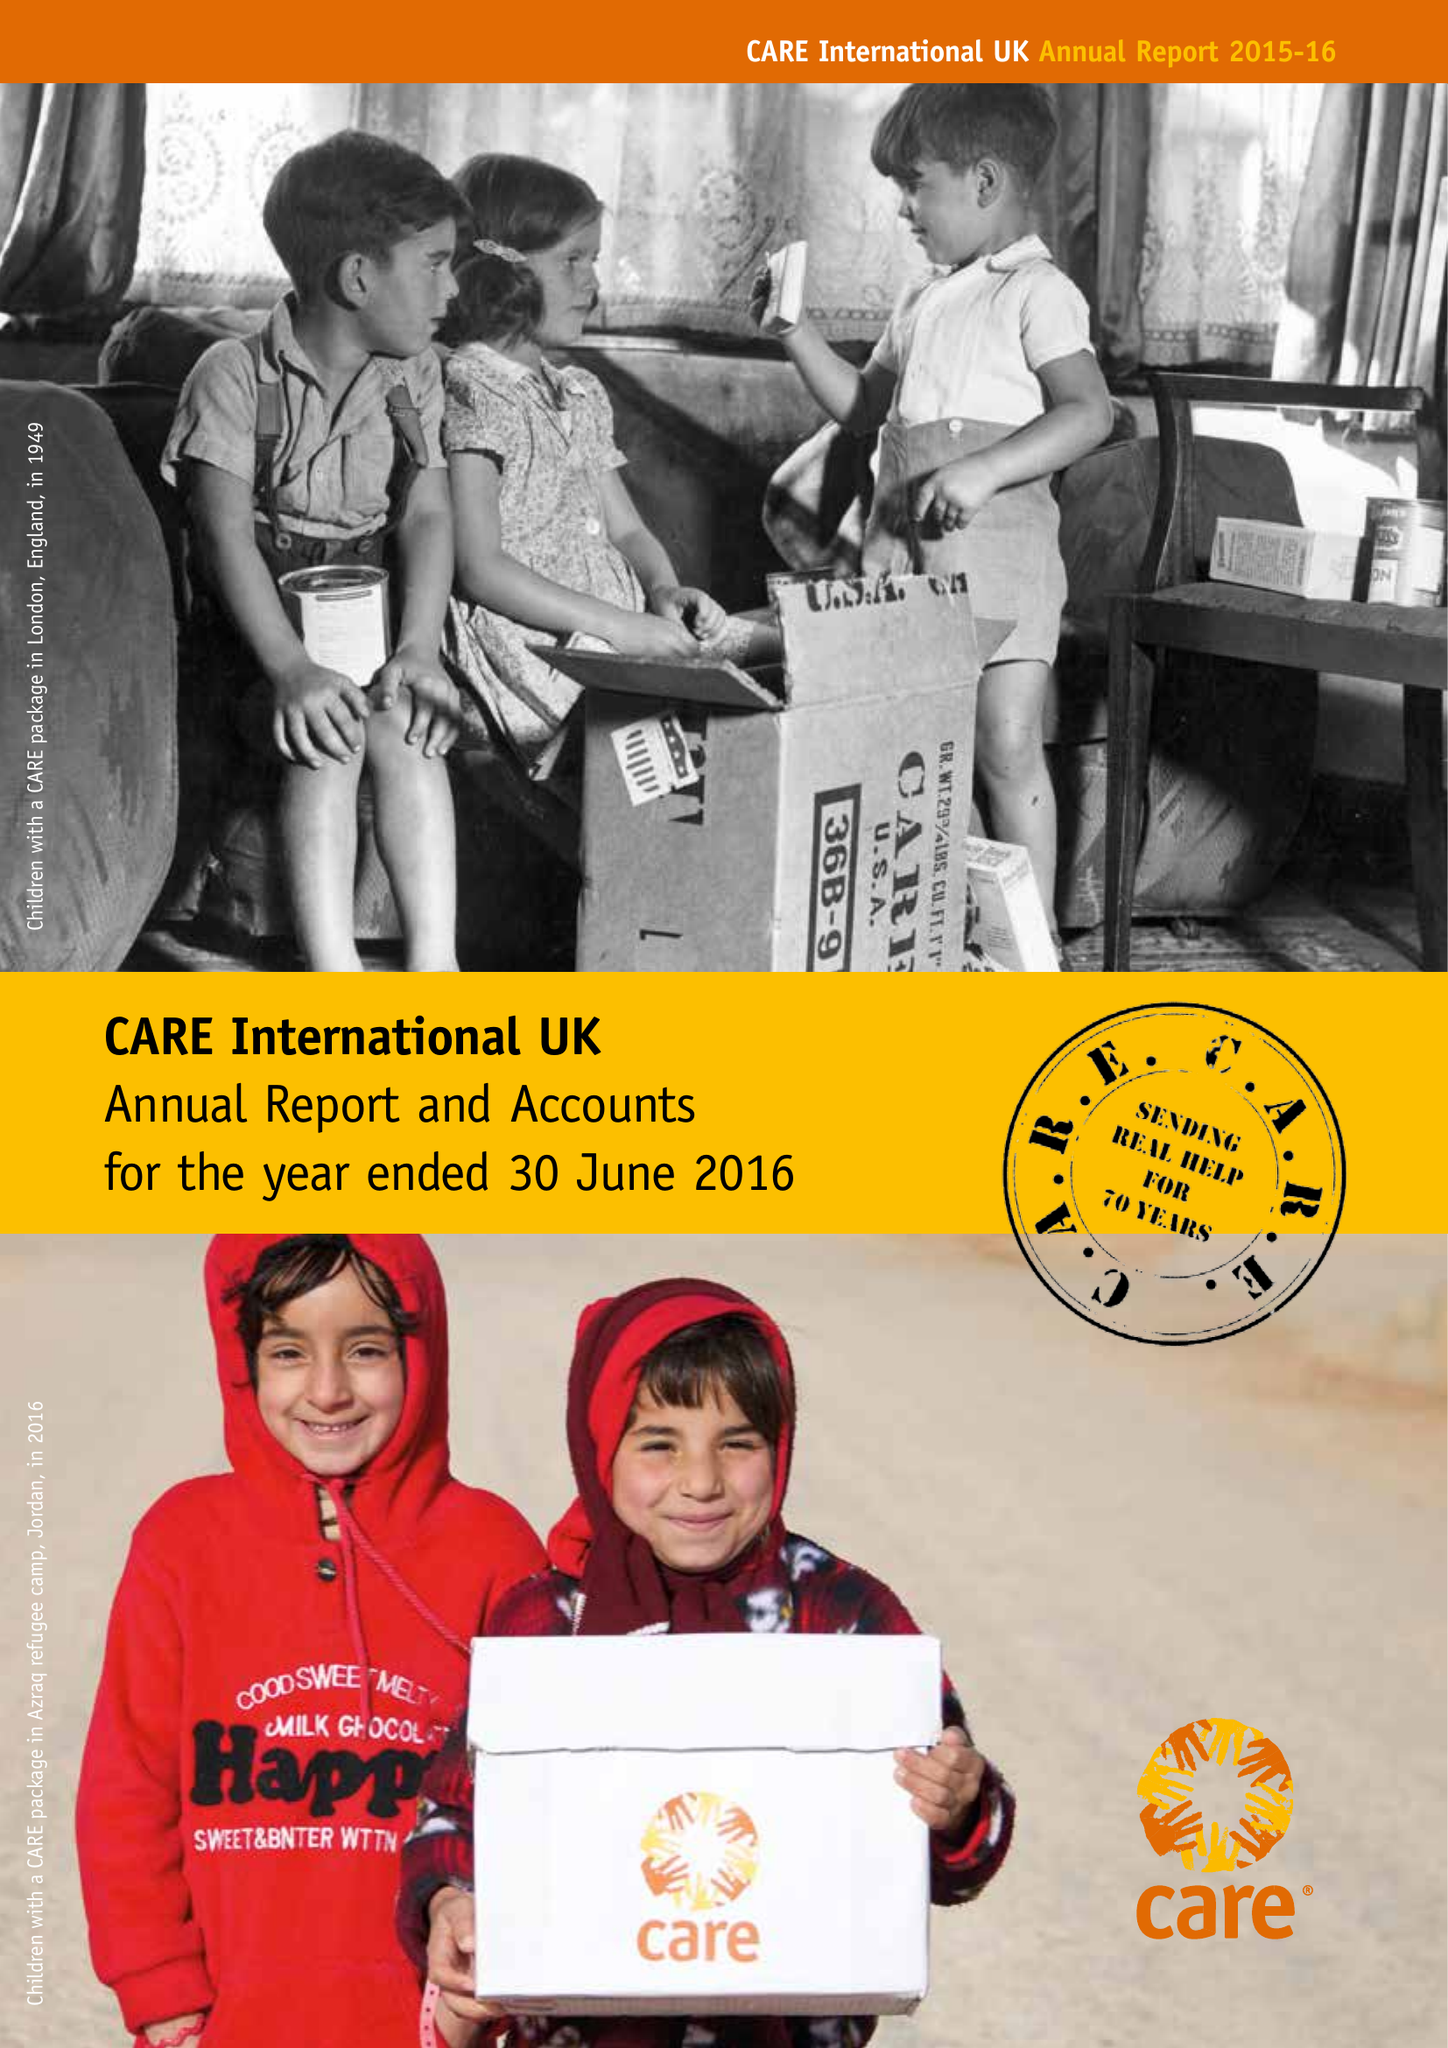What is the value for the address__post_town?
Answer the question using a single word or phrase. LONDON 